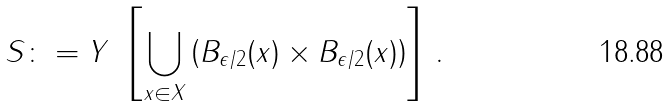Convert formula to latex. <formula><loc_0><loc_0><loc_500><loc_500>S \colon = Y \ \left [ \bigcup _ { x \in X } \left ( B _ { \epsilon / 2 } ( x ) \times B _ { \epsilon / 2 } ( x ) \right ) \right ] \, .</formula> 